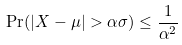<formula> <loc_0><loc_0><loc_500><loc_500>\Pr ( | X - \mu | > \alpha \sigma ) \leq \frac { 1 } { \alpha ^ { 2 } }</formula> 